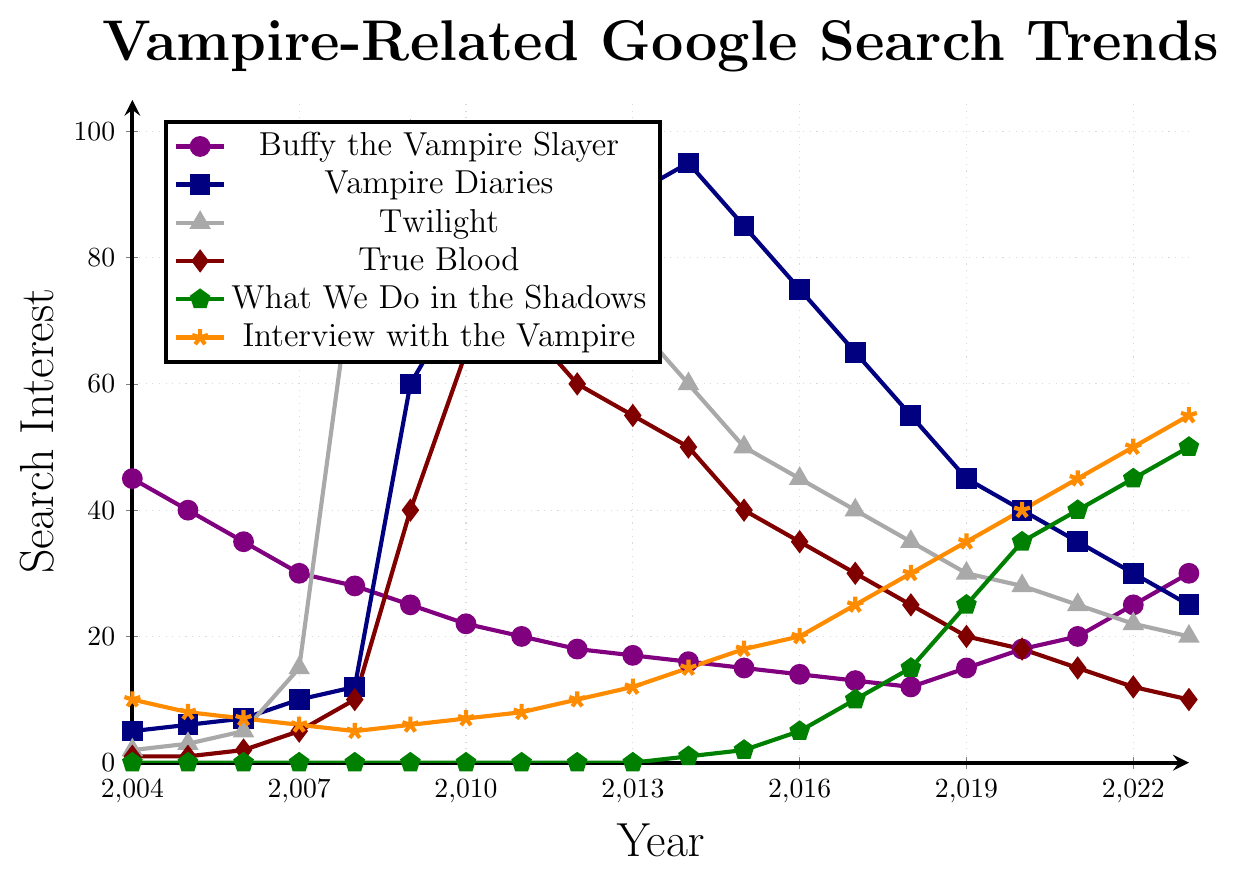Which year shows the peak interest in "Twilight"? To determine the peak interest in "Twilight," examine the trend line marked with triangles. The highest point is in 2009.
Answer: 2009 How does the interest in "Buffy the Vampire Slayer" in 2009 compare to its interest in 2023? Look at the points for "Buffy the Vampire Slayer" in 2009 (25) and 2023 (30). Compare the values directly.
Answer: The interest increased from 25 to 30 Which series had the highest peak interest overall? Compare the highest points of all the series. "Twilight" peaks at 100 in 2009.
Answer: Twilight What is the average search interest for "Buffy the Vampire Slayer" from 2020 to 2023? Calculate the average of the values from 2020, 2021, 2022, and 2023: (18+20+25+30)/4 = 23.25
Answer: 23.25 What color represents "What We Do in the Shadows"? Identify the series' color by its line and legend entry. "What We Do in the Shadows" is marked with a green line.
Answer: Green Compare the initial search interest for "Interview with the Vampire" in 2004 and its value in 2023. "Interview with the Vampire" has a value of 10 in 2004 and 55 in 2023. Compare these two values.
Answer: The interest increased from 10 to 55 In which year did "True Blood" show the most significant increase? Look for the year with the steepest upward slope in the "True Blood" line. The most significant increase is between 2008 (10) and 2009 (40).
Answer: 2009 What is the sum of the search interest values for "Vampire Diaries" from 2012 to 2014? Add the values: 85 (2012) + 90 (2013) + 95 (2014) = 270
Answer: 270 Which series shows a consistent increase in search interest over the years? Look for the line with a constant upward trend. "What We Do in the Shadows" shows consistent growth.
Answer: What We Do in the Shadows What is the difference in search interest for "True Blood" between 2013 and 2019? Subtract the search interest in 2019 (20) from 2013 (55): 55 - 20 = 35
Answer: 35 